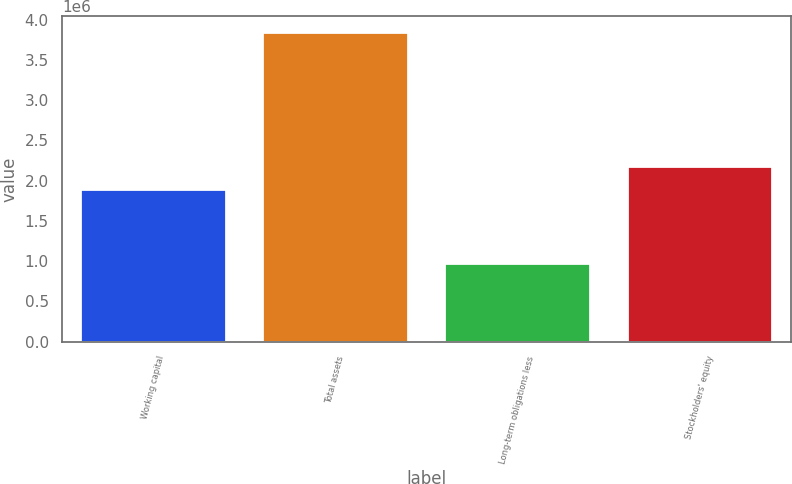<chart> <loc_0><loc_0><loc_500><loc_500><bar_chart><fcel>Working capital<fcel>Total assets<fcel>Long-term obligations less<fcel>Stockholders' equity<nl><fcel>1.89476e+06<fcel>3.8514e+06<fcel>983385<fcel>2.18156e+06<nl></chart> 